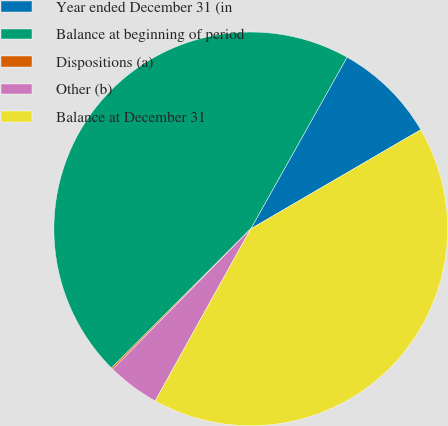Convert chart to OTSL. <chart><loc_0><loc_0><loc_500><loc_500><pie_chart><fcel>Year ended December 31 (in<fcel>Balance at beginning of period<fcel>Dispositions (a)<fcel>Other (b)<fcel>Balance at December 31<nl><fcel>8.46%<fcel>45.63%<fcel>0.14%<fcel>4.3%<fcel>41.47%<nl></chart> 